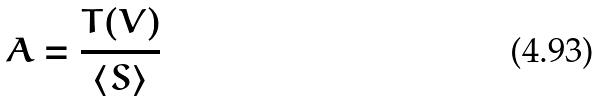Convert formula to latex. <formula><loc_0><loc_0><loc_500><loc_500>A = \frac { T ( V ) } { \langle S \rangle }</formula> 